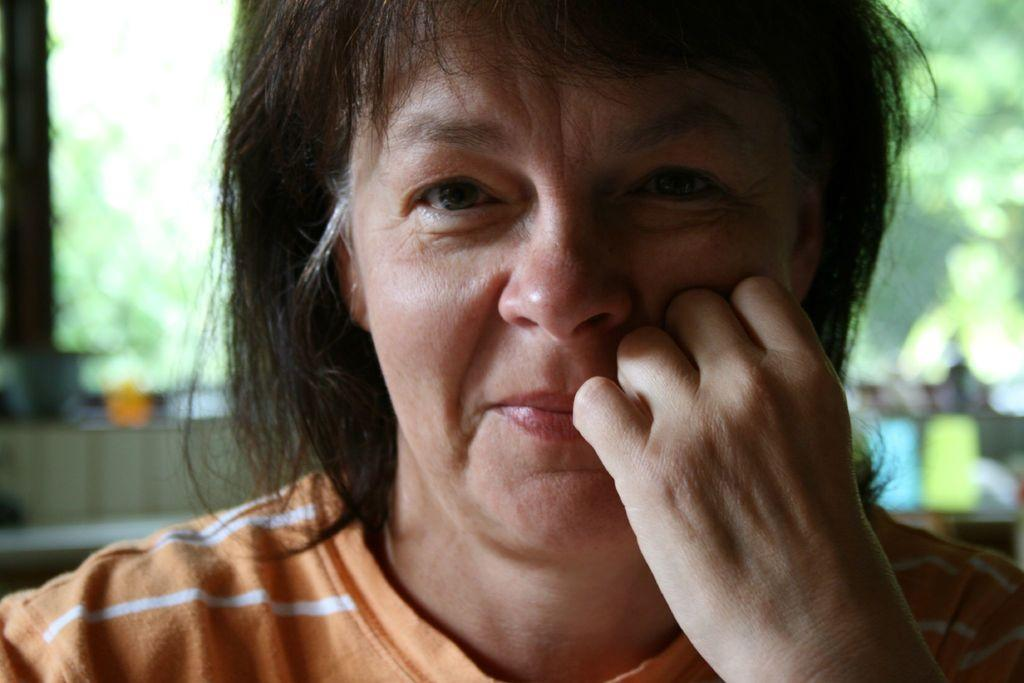Who is present in the image? There is a woman in the picture. What expression does the woman have? The woman is smiling. Can you describe the background of the image? The background of the image is blurred. What type of jewel is the woman wearing in the image? There is no mention of a jewel in the image, so it cannot be determined if the woman is wearing one. 